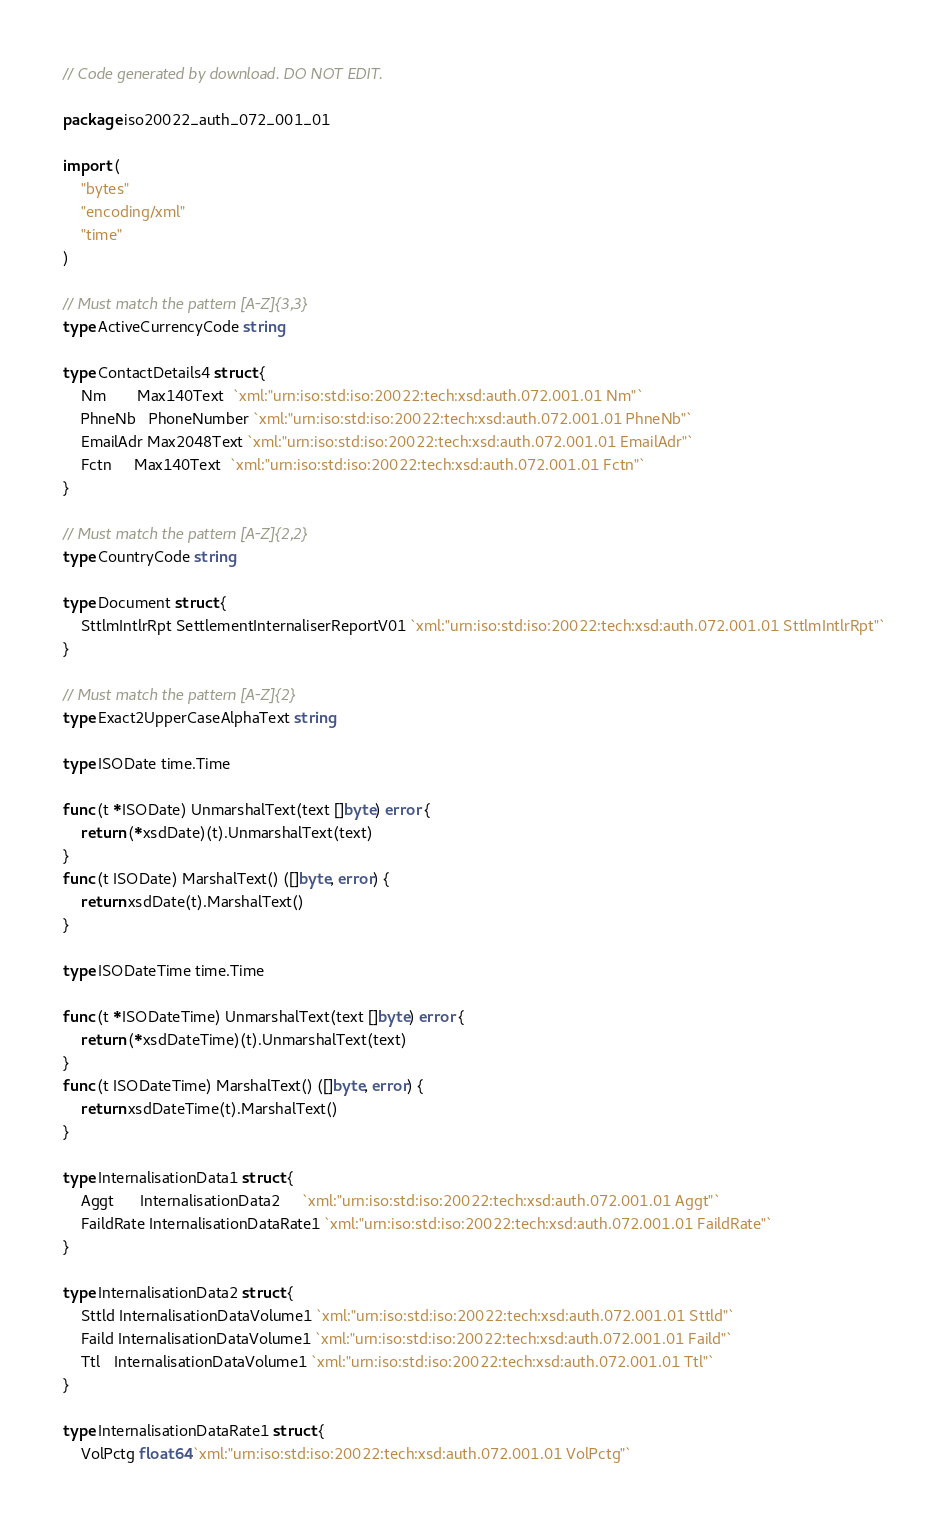<code> <loc_0><loc_0><loc_500><loc_500><_Go_>// Code generated by download. DO NOT EDIT.

package iso20022_auth_072_001_01

import (
	"bytes"
	"encoding/xml"
	"time"
)

// Must match the pattern [A-Z]{3,3}
type ActiveCurrencyCode string

type ContactDetails4 struct {
	Nm       Max140Text  `xml:"urn:iso:std:iso:20022:tech:xsd:auth.072.001.01 Nm"`
	PhneNb   PhoneNumber `xml:"urn:iso:std:iso:20022:tech:xsd:auth.072.001.01 PhneNb"`
	EmailAdr Max2048Text `xml:"urn:iso:std:iso:20022:tech:xsd:auth.072.001.01 EmailAdr"`
	Fctn     Max140Text  `xml:"urn:iso:std:iso:20022:tech:xsd:auth.072.001.01 Fctn"`
}

// Must match the pattern [A-Z]{2,2}
type CountryCode string

type Document struct {
	SttlmIntlrRpt SettlementInternaliserReportV01 `xml:"urn:iso:std:iso:20022:tech:xsd:auth.072.001.01 SttlmIntlrRpt"`
}

// Must match the pattern [A-Z]{2}
type Exact2UpperCaseAlphaText string

type ISODate time.Time

func (t *ISODate) UnmarshalText(text []byte) error {
	return (*xsdDate)(t).UnmarshalText(text)
}
func (t ISODate) MarshalText() ([]byte, error) {
	return xsdDate(t).MarshalText()
}

type ISODateTime time.Time

func (t *ISODateTime) UnmarshalText(text []byte) error {
	return (*xsdDateTime)(t).UnmarshalText(text)
}
func (t ISODateTime) MarshalText() ([]byte, error) {
	return xsdDateTime(t).MarshalText()
}

type InternalisationData1 struct {
	Aggt      InternalisationData2     `xml:"urn:iso:std:iso:20022:tech:xsd:auth.072.001.01 Aggt"`
	FaildRate InternalisationDataRate1 `xml:"urn:iso:std:iso:20022:tech:xsd:auth.072.001.01 FaildRate"`
}

type InternalisationData2 struct {
	Sttld InternalisationDataVolume1 `xml:"urn:iso:std:iso:20022:tech:xsd:auth.072.001.01 Sttld"`
	Faild InternalisationDataVolume1 `xml:"urn:iso:std:iso:20022:tech:xsd:auth.072.001.01 Faild"`
	Ttl   InternalisationDataVolume1 `xml:"urn:iso:std:iso:20022:tech:xsd:auth.072.001.01 Ttl"`
}

type InternalisationDataRate1 struct {
	VolPctg float64 `xml:"urn:iso:std:iso:20022:tech:xsd:auth.072.001.01 VolPctg"`</code> 